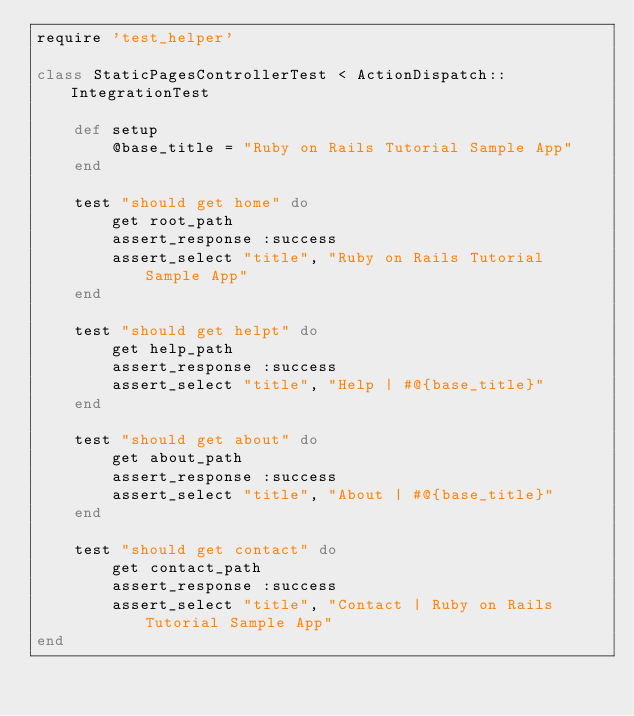<code> <loc_0><loc_0><loc_500><loc_500><_Ruby_>require 'test_helper'

class StaticPagesControllerTest < ActionDispatch::IntegrationTest

    def setup
        @base_title = "Ruby on Rails Tutorial Sample App"
    end

    test "should get home" do
        get root_path
        assert_response :success
        assert_select "title", "Ruby on Rails Tutorial Sample App"
    end

    test "should get helpt" do
        get help_path
        assert_response :success
        assert_select "title", "Help | #@{base_title}"
    end

    test "should get about" do
        get about_path
        assert_response :success
        assert_select "title", "About | #@{base_title}"
    end

    test "should get contact" do
        get contact_path
        assert_response :success
        assert_select "title", "Contact | Ruby on Rails Tutorial Sample App"
end</code> 